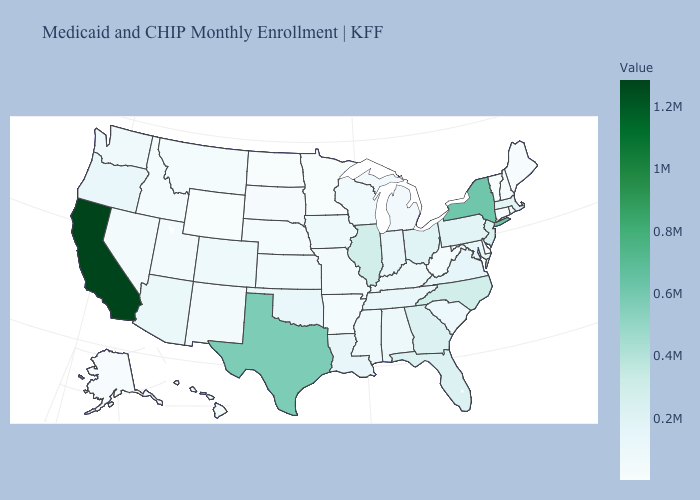Is the legend a continuous bar?
Quick response, please. Yes. Among the states that border Wyoming , does Colorado have the lowest value?
Give a very brief answer. No. Which states have the lowest value in the USA?
Keep it brief. Minnesota. Does California have the highest value in the USA?
Be succinct. Yes. Does Wisconsin have a lower value than Florida?
Answer briefly. Yes. 